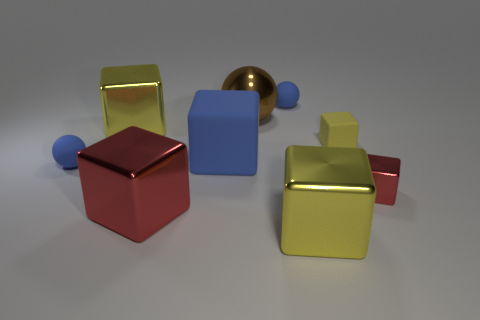Subtract all tiny red shiny blocks. How many blocks are left? 5 Subtract 2 spheres. How many spheres are left? 1 Subtract all blue blocks. How many blocks are left? 5 Subtract all brown spheres. Subtract all gray cylinders. How many spheres are left? 2 Subtract all purple spheres. How many brown cubes are left? 0 Add 3 big red blocks. How many big red blocks exist? 4 Subtract 0 cyan cylinders. How many objects are left? 9 Subtract all cubes. How many objects are left? 3 Subtract all big blue matte blocks. Subtract all metallic spheres. How many objects are left? 7 Add 5 big blue cubes. How many big blue cubes are left? 6 